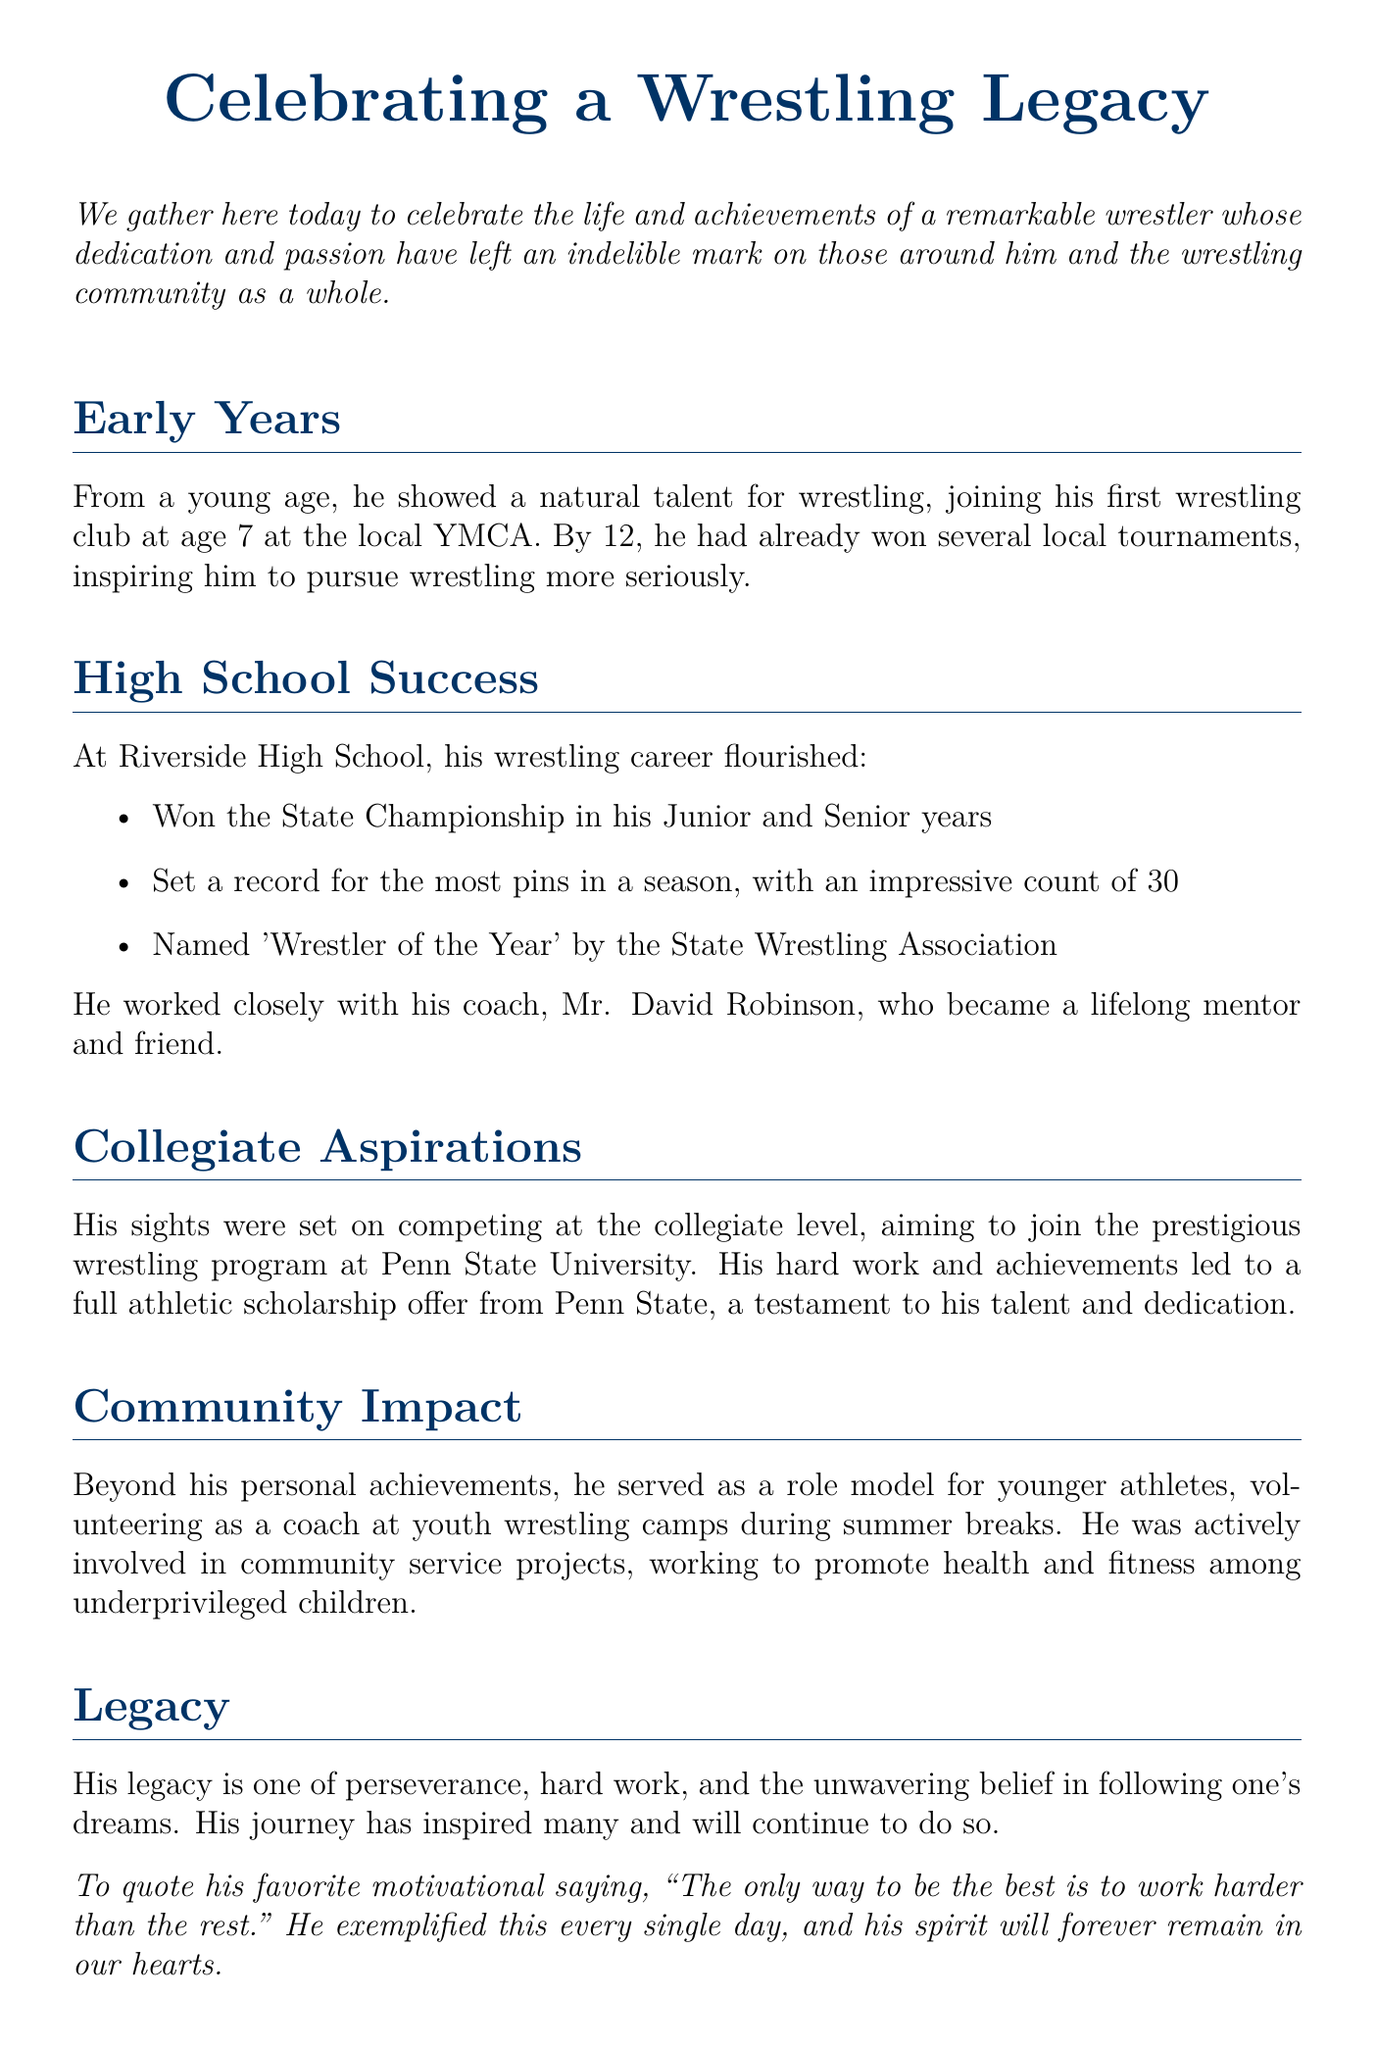What age did he join his first wrestling club? The document states he joined his first wrestling club at age 7.
Answer: 7 How many times did he win the State Championship? The document mentions he won the State Championship in his Junior and Senior years, totaling two wins.
Answer: 2 What record did he set during high school? The document specifies that he set a record for the most pins in a season, with an impressive count of 30.
Answer: most pins in a season: 30 Who was his wrestling coach at Riverside High School? The document names Mr. David Robinson as his wrestling coach and lifelong mentor.
Answer: Mr. David Robinson Which college's wrestling program did he aspire to join? The document indicates that he aimed to join the wrestling program at Penn State University.
Answer: Penn State University What scholarship did he receive due to his achievements? The document states that he received a full athletic scholarship offer from Penn State.
Answer: full athletic scholarship What community service did he participate in? The document mentions he volunteered as a coach at youth wrestling camps during summer breaks.
Answer: coaching youth wrestling camps What was his favorite motivational saying? The document quotes his favorite motivational saying, emphasizing hard work.
Answer: "The only way to be the best is to work harder than the rest." What was his legacy described as? The document describes his legacy as one of perseverance, hard work, and the unwavering belief in following one's dreams.
Answer: perseverance, hard work, and following one's dreams 